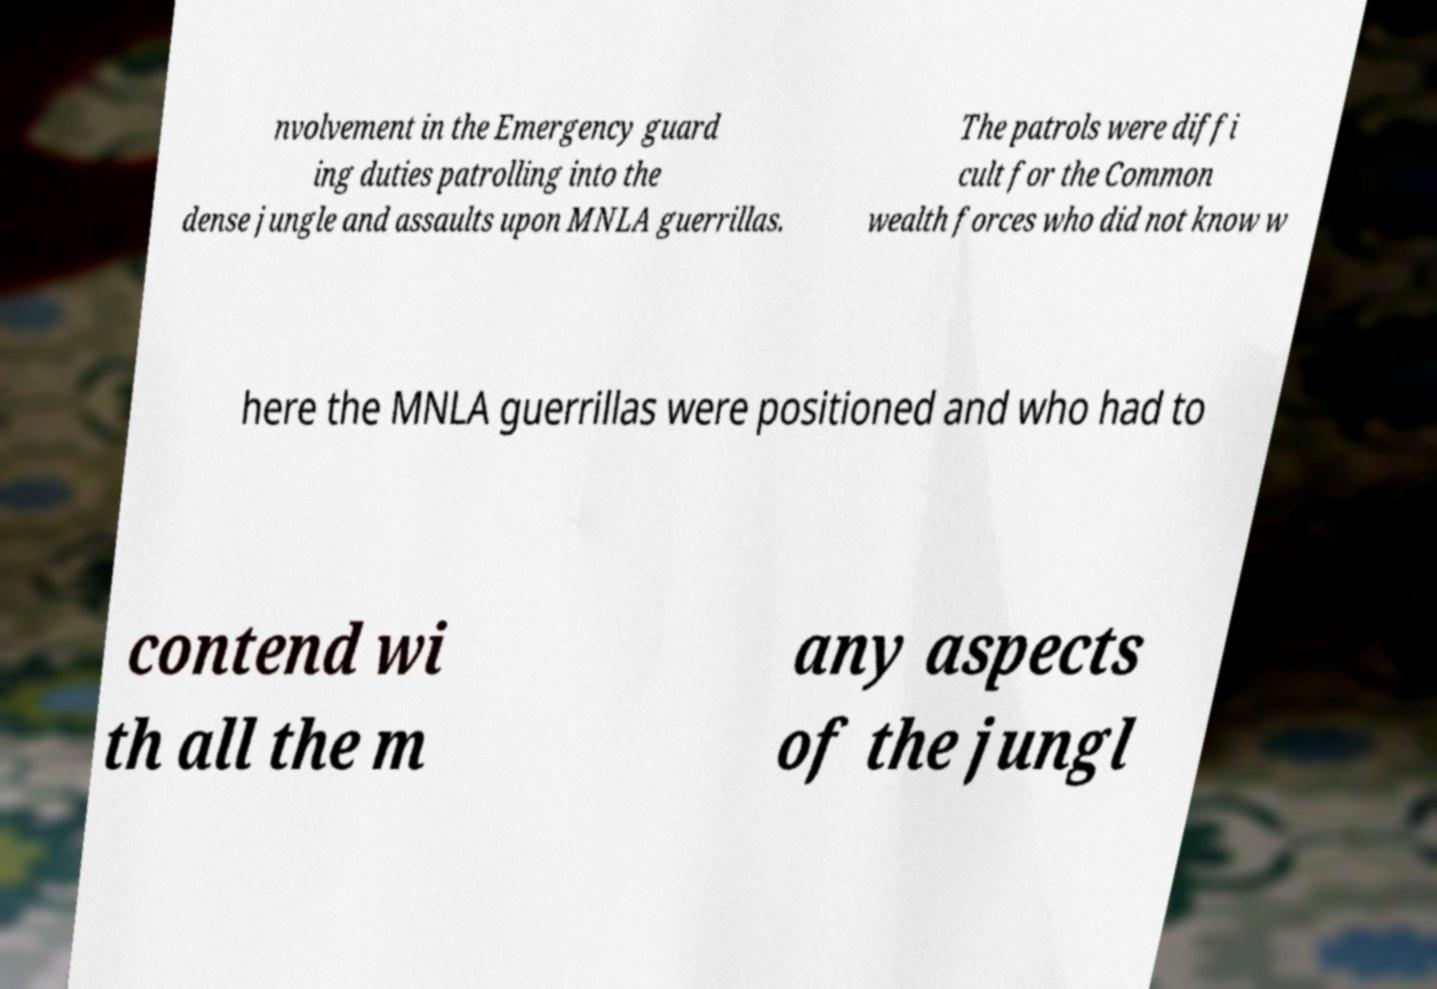Can you read and provide the text displayed in the image?This photo seems to have some interesting text. Can you extract and type it out for me? nvolvement in the Emergency guard ing duties patrolling into the dense jungle and assaults upon MNLA guerrillas. The patrols were diffi cult for the Common wealth forces who did not know w here the MNLA guerrillas were positioned and who had to contend wi th all the m any aspects of the jungl 